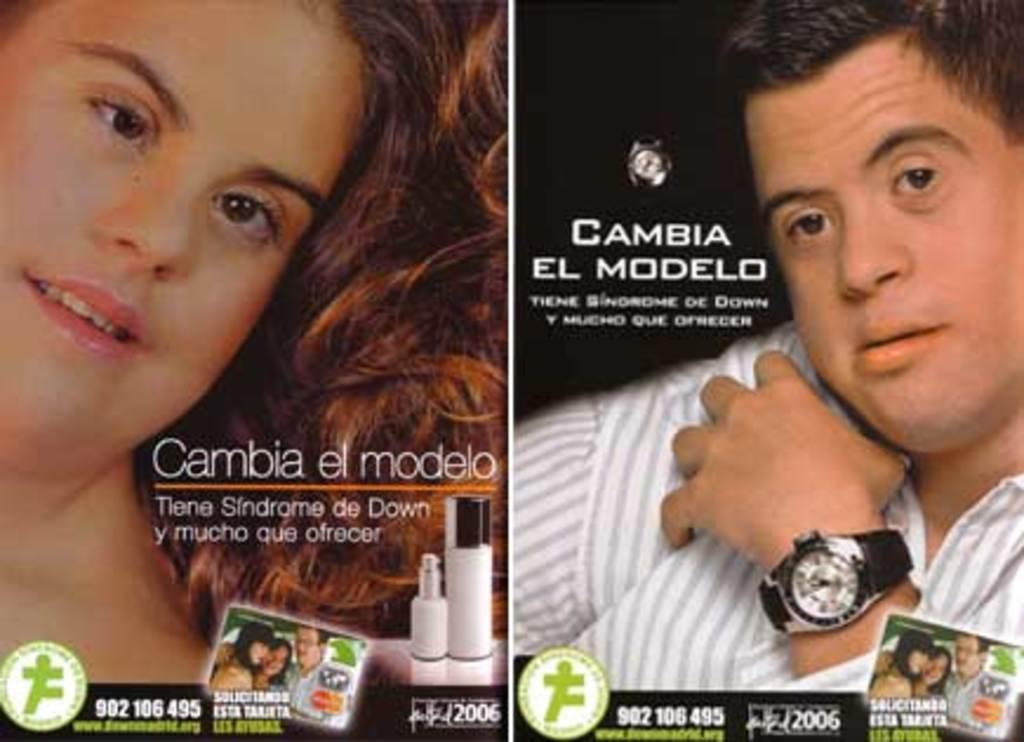<image>
Summarize the visual content of the image. A man and a woman both model Cambia El Modela watch's 